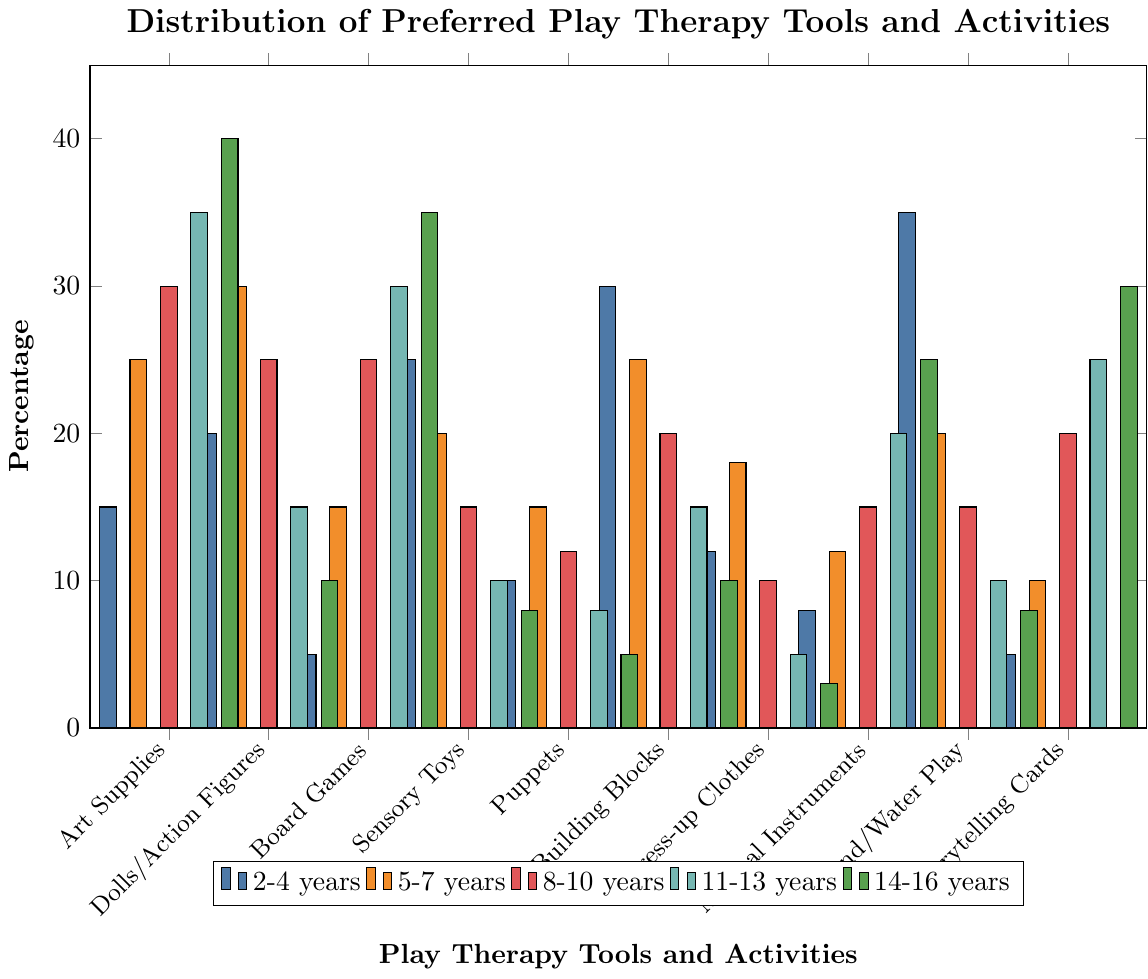What is the most preferred play therapy tool or activity for the 2-4 years age group? The tallest bar for the 2-4 years age group is for Sand/Water Play at 35%.
Answer: Sand/Water Play Which age group shows the highest preference for Board Games? The 14-16 years age group has the tallest bar for Board Games at 35%.
Answer: 14-16 years How does the preference for Art Supplies change as the age group increases? The height of the bars for Art Supplies increases as the age group rises: 15% for 2-4 years, 25% for 5-7 years, 30% for 8-10 years, 35% for 11-13 years, and 40% for 14-16 years.
Answer: Increases Compare the preference for Sensory Toys between age groups 2-4 years and 5-7 years. The 2-4 years age group has a bar height of 25% for Sensory Toys, while the 5-7 years age group's bar is 20%.
Answer: Higher in 2-4 years What is the least preferred play therapy tool or activity for the 14-16 years age group? The shortest bar for the 14-16 years age group is Dress-up Clothes at 3%.
Answer: Dress-up Clothes What is the total preference percentage for Musical Instruments across all age groups? Sum the heights of the bars for Musical Instruments: 8% (2-4 years) + 12% (5-7 years) + 15% (8-10 years) + 20% (11-13 years) + 25% (14-16 years) = 80%.
Answer: 80% Which two play therapy tools or activities have the same preference in the 8-10 years age group? The bars for Board Games and Dolls/Action Figures are both at 25% for the 8-10 years age group.
Answer: Board Games and Dolls/Action Figures What is the average preference for Puppets across all age groups? Sum the heights of the bars for Puppets: 10% (2-4 years) + 15% (5-7 years) + 12% (8-10 years) + 8% (11-13 years) + 5% (14-16 years) = 50%; then divide by 5 age groups: 50%/5 = 10%.
Answer: 10% How does the preference for Storytelling Cards compare between the 2-4 years and 14-16 years age groups? The height of the bar for Storytelling Cards is 5% for 2-4 years and 30% for 14-16 years.
Answer: Higher in 14-16 years Which age group has equal preferences for Musical Instruments and Storytelling Cards? The 8-10 years age group's bars for Musical Instruments and Storytelling Cards are both at 15%.
Answer: 8-10 years 